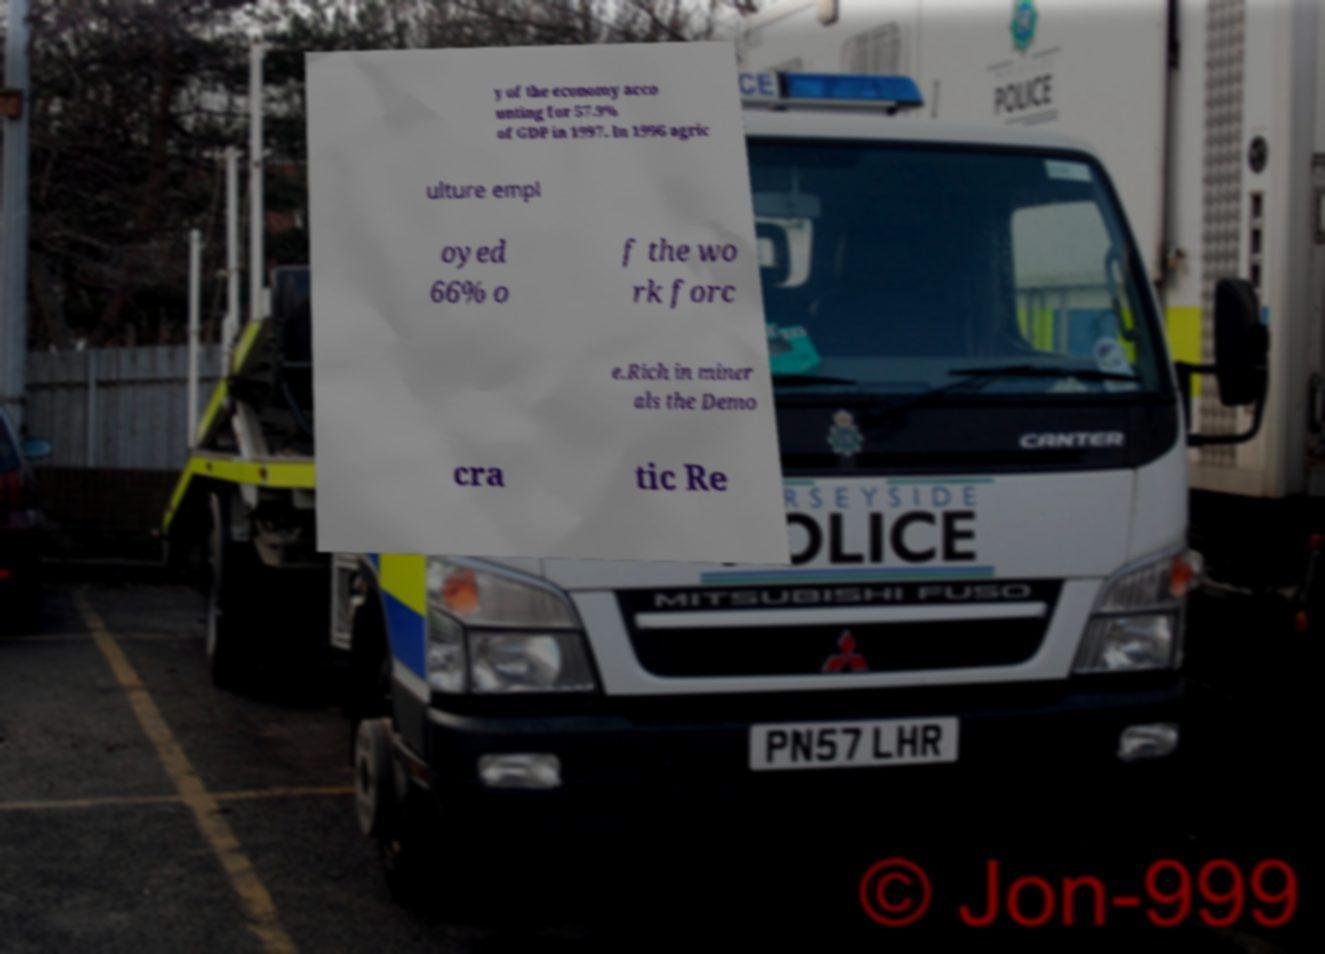Can you accurately transcribe the text from the provided image for me? y of the economy acco unting for 57.9% of GDP in 1997. In 1996 agric ulture empl oyed 66% o f the wo rk forc e.Rich in miner als the Demo cra tic Re 